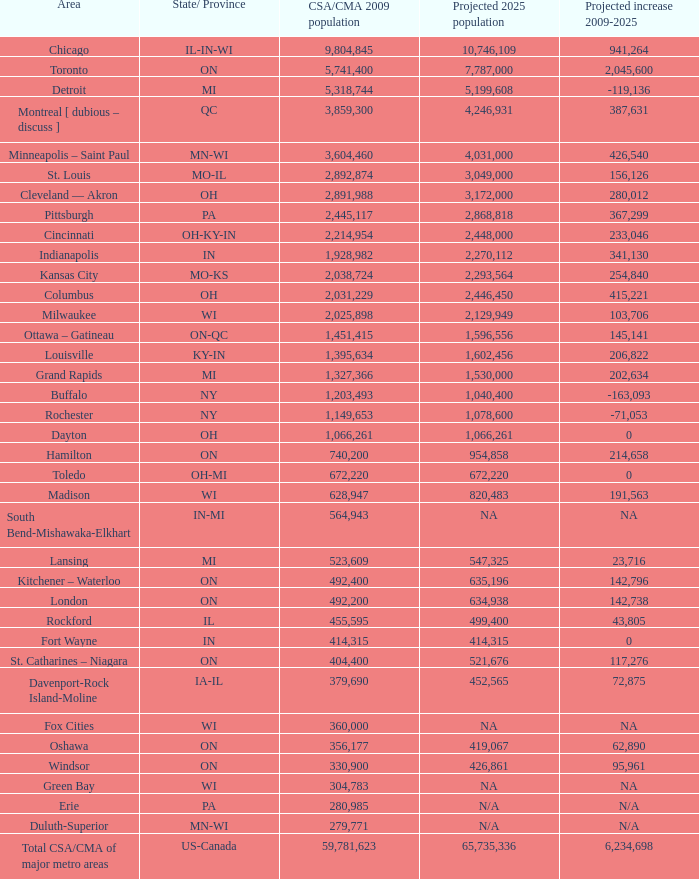What is the estimated population for in-mi in the future? NA. 